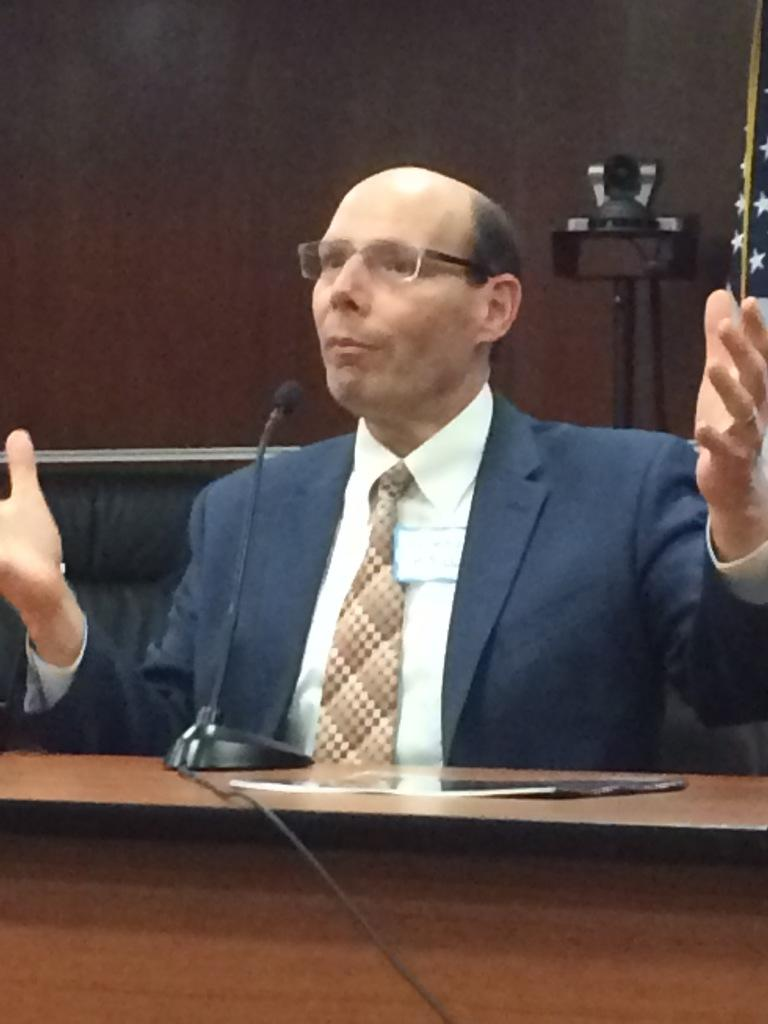Who is the main subject in the image? There is a man in the image. What is the man doing in the image? The man is sitting on a chair and in front of a mic. What can be seen in the background of the image? There is a wall and a camera in the background of the image. How many balloons are floating around the man in the image? There are no balloons present in the image. What type of kick is the man performing in the image? The man is not performing any kick in the image; he is sitting on a chair and in front of a mic. 